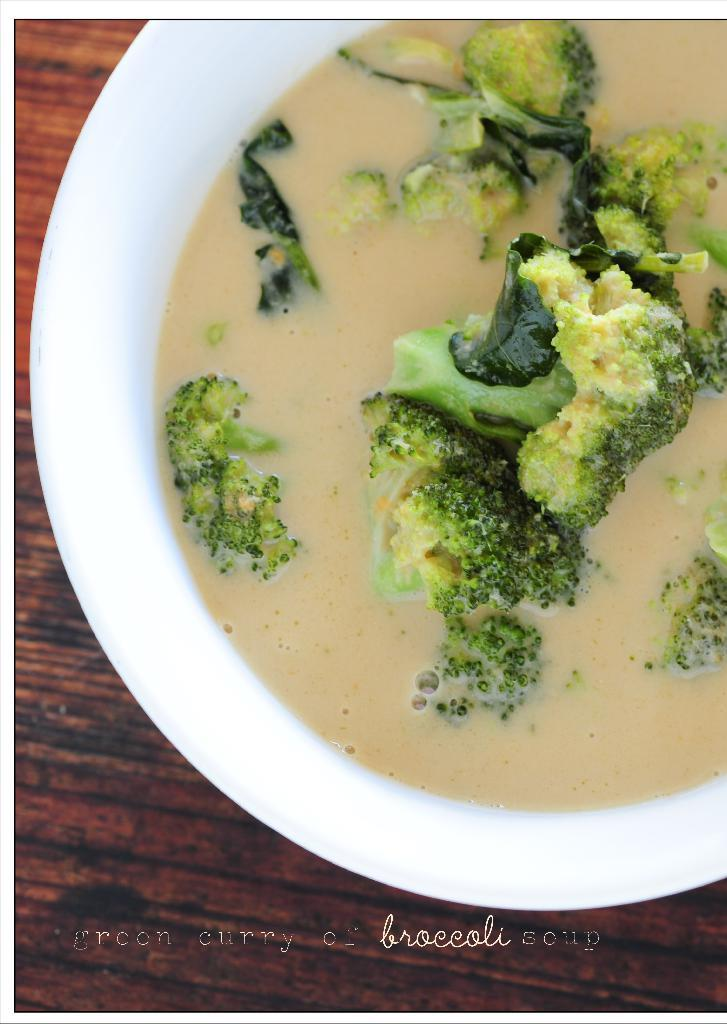What type of structure is present on the wooden platform in the image? There is a bowl with food on the wooden platform in the image. Can you describe the wooden platform in the image? The wooden platform is a flat surface that supports the bowl with food. What type of tank is visible in the image? There is no tank present in the image. Can you recite a verse from a poem that is related to the image? There is no poem or verse mentioned or depicted in the image. 